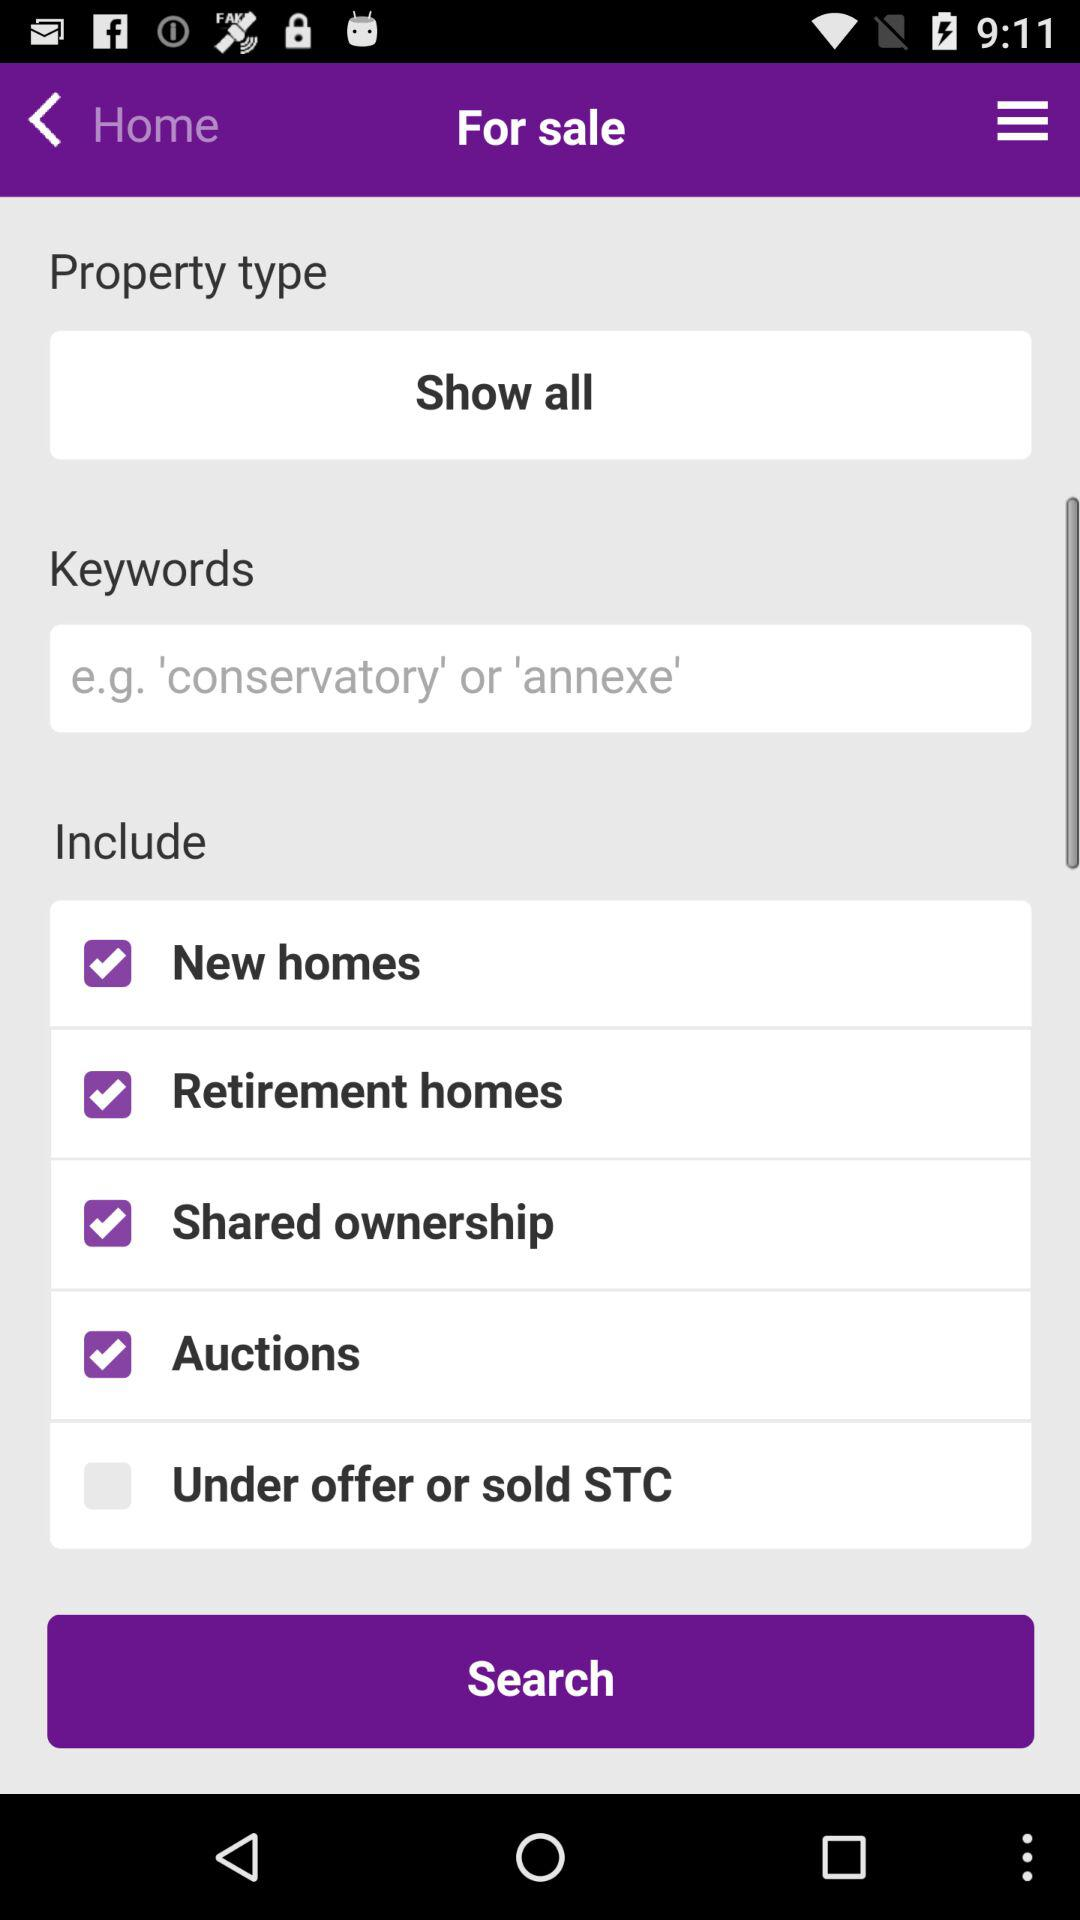What is the selected category of the property being searched? The selected category is "For sale". 